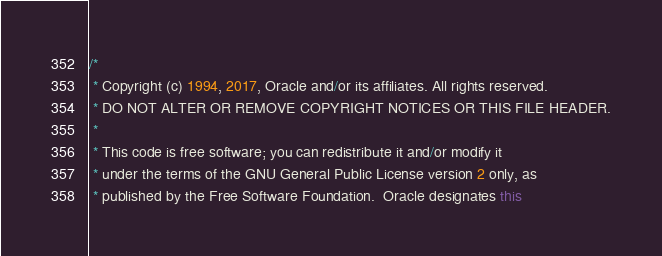<code> <loc_0><loc_0><loc_500><loc_500><_Java_>/*
 * Copyright (c) 1994, 2017, Oracle and/or its affiliates. All rights reserved.
 * DO NOT ALTER OR REMOVE COPYRIGHT NOTICES OR THIS FILE HEADER.
 *
 * This code is free software; you can redistribute it and/or modify it
 * under the terms of the GNU General Public License version 2 only, as
 * published by the Free Software Foundation.  Oracle designates this</code> 